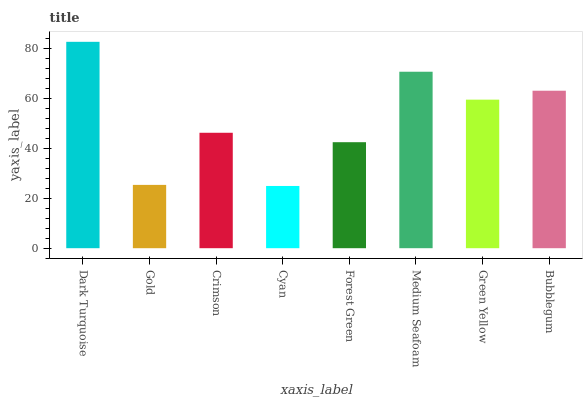Is Gold the minimum?
Answer yes or no. No. Is Gold the maximum?
Answer yes or no. No. Is Dark Turquoise greater than Gold?
Answer yes or no. Yes. Is Gold less than Dark Turquoise?
Answer yes or no. Yes. Is Gold greater than Dark Turquoise?
Answer yes or no. No. Is Dark Turquoise less than Gold?
Answer yes or no. No. Is Green Yellow the high median?
Answer yes or no. Yes. Is Crimson the low median?
Answer yes or no. Yes. Is Cyan the high median?
Answer yes or no. No. Is Green Yellow the low median?
Answer yes or no. No. 